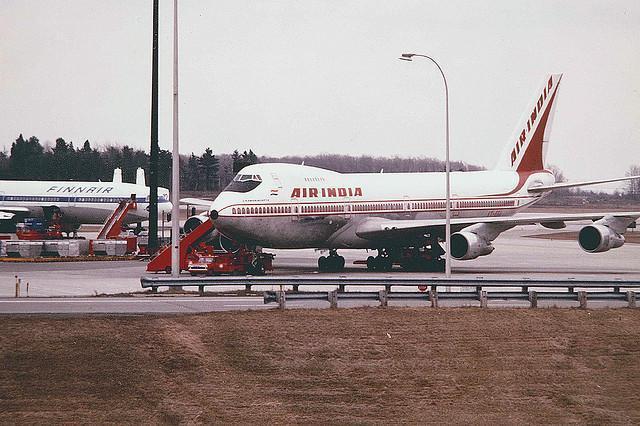How many airplanes are there?
Give a very brief answer. 2. How many cows are there?
Give a very brief answer. 0. 